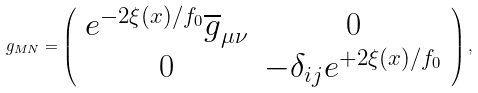Convert formula to latex. <formula><loc_0><loc_0><loc_500><loc_500>g _ { M N } = \left ( \begin{array} { c c } e ^ { - 2 \xi ( x ) / f _ { 0 } } \overline { g } _ { \mu \nu } & 0 \\ 0 & - \delta _ { i j } e ^ { + 2 \xi ( x ) / f _ { 0 } } \end{array} \right ) ,</formula> 